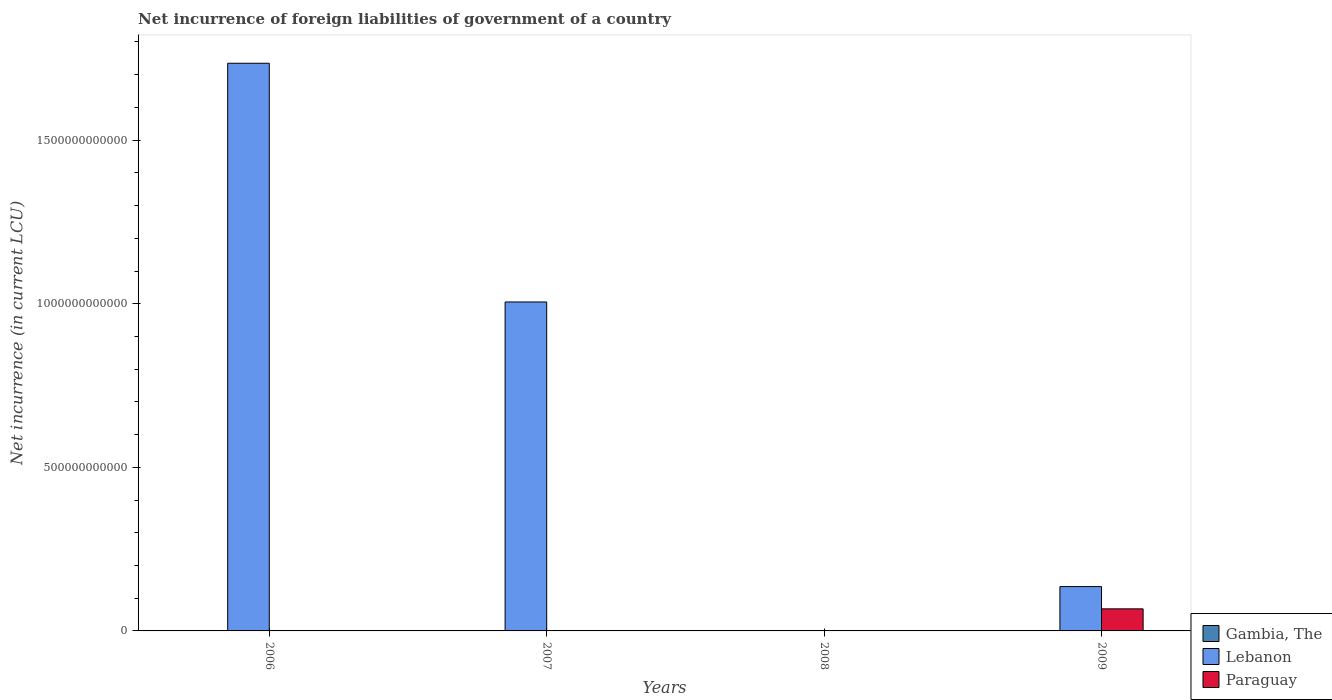Are the number of bars per tick equal to the number of legend labels?
Ensure brevity in your answer.  No. Are the number of bars on each tick of the X-axis equal?
Keep it short and to the point. No. How many bars are there on the 3rd tick from the left?
Your answer should be very brief. 1. How many bars are there on the 1st tick from the right?
Keep it short and to the point. 3. What is the label of the 2nd group of bars from the left?
Your response must be concise. 2007. In how many cases, is the number of bars for a given year not equal to the number of legend labels?
Keep it short and to the point. 3. What is the net incurrence of foreign liabilities in Gambia, The in 2008?
Give a very brief answer. 1.13e+07. Across all years, what is the maximum net incurrence of foreign liabilities in Paraguay?
Offer a terse response. 6.75e+1. Across all years, what is the minimum net incurrence of foreign liabilities in Lebanon?
Your answer should be very brief. 0. In which year was the net incurrence of foreign liabilities in Lebanon maximum?
Offer a very short reply. 2006. What is the total net incurrence of foreign liabilities in Paraguay in the graph?
Your answer should be very brief. 6.75e+1. What is the difference between the net incurrence of foreign liabilities in Gambia, The in 2007 and that in 2008?
Provide a short and direct response. 6.50e+08. What is the difference between the net incurrence of foreign liabilities in Paraguay in 2009 and the net incurrence of foreign liabilities in Gambia, The in 2006?
Offer a terse response. 6.71e+1. What is the average net incurrence of foreign liabilities in Gambia, The per year?
Offer a terse response. 2.56e+08. In the year 2009, what is the difference between the net incurrence of foreign liabilities in Paraguay and net incurrence of foreign liabilities in Gambia, The?
Your response must be concise. 6.74e+1. In how many years, is the net incurrence of foreign liabilities in Lebanon greater than 900000000000 LCU?
Keep it short and to the point. 2. What is the ratio of the net incurrence of foreign liabilities in Gambia, The in 2008 to that in 2009?
Provide a succinct answer. 0.27. Is the net incurrence of foreign liabilities in Gambia, The in 2006 less than that in 2009?
Ensure brevity in your answer.  No. What is the difference between the highest and the second highest net incurrence of foreign liabilities in Lebanon?
Make the answer very short. 7.30e+11. What is the difference between the highest and the lowest net incurrence of foreign liabilities in Paraguay?
Keep it short and to the point. 6.75e+1. Are all the bars in the graph horizontal?
Offer a terse response. No. How many years are there in the graph?
Keep it short and to the point. 4. What is the difference between two consecutive major ticks on the Y-axis?
Offer a very short reply. 5.00e+11. Does the graph contain grids?
Make the answer very short. No. How are the legend labels stacked?
Your answer should be very brief. Vertical. What is the title of the graph?
Keep it short and to the point. Net incurrence of foreign liabilities of government of a country. What is the label or title of the X-axis?
Give a very brief answer. Years. What is the label or title of the Y-axis?
Offer a very short reply. Net incurrence (in current LCU). What is the Net incurrence (in current LCU) of Gambia, The in 2006?
Your answer should be very brief. 3.09e+08. What is the Net incurrence (in current LCU) of Lebanon in 2006?
Offer a very short reply. 1.74e+12. What is the Net incurrence (in current LCU) in Gambia, The in 2007?
Offer a terse response. 6.62e+08. What is the Net incurrence (in current LCU) of Lebanon in 2007?
Offer a terse response. 1.01e+12. What is the Net incurrence (in current LCU) in Gambia, The in 2008?
Provide a succinct answer. 1.13e+07. What is the Net incurrence (in current LCU) in Paraguay in 2008?
Your response must be concise. 0. What is the Net incurrence (in current LCU) of Gambia, The in 2009?
Offer a terse response. 4.18e+07. What is the Net incurrence (in current LCU) of Lebanon in 2009?
Provide a short and direct response. 1.35e+11. What is the Net incurrence (in current LCU) in Paraguay in 2009?
Your answer should be compact. 6.75e+1. Across all years, what is the maximum Net incurrence (in current LCU) in Gambia, The?
Give a very brief answer. 6.62e+08. Across all years, what is the maximum Net incurrence (in current LCU) of Lebanon?
Give a very brief answer. 1.74e+12. Across all years, what is the maximum Net incurrence (in current LCU) of Paraguay?
Provide a short and direct response. 6.75e+1. Across all years, what is the minimum Net incurrence (in current LCU) in Gambia, The?
Offer a terse response. 1.13e+07. Across all years, what is the minimum Net incurrence (in current LCU) in Lebanon?
Give a very brief answer. 0. Across all years, what is the minimum Net incurrence (in current LCU) of Paraguay?
Give a very brief answer. 0. What is the total Net incurrence (in current LCU) in Gambia, The in the graph?
Provide a succinct answer. 1.02e+09. What is the total Net incurrence (in current LCU) in Lebanon in the graph?
Your response must be concise. 2.88e+12. What is the total Net incurrence (in current LCU) of Paraguay in the graph?
Make the answer very short. 6.75e+1. What is the difference between the Net incurrence (in current LCU) in Gambia, The in 2006 and that in 2007?
Provide a short and direct response. -3.52e+08. What is the difference between the Net incurrence (in current LCU) in Lebanon in 2006 and that in 2007?
Make the answer very short. 7.30e+11. What is the difference between the Net incurrence (in current LCU) of Gambia, The in 2006 and that in 2008?
Make the answer very short. 2.98e+08. What is the difference between the Net incurrence (in current LCU) of Gambia, The in 2006 and that in 2009?
Provide a succinct answer. 2.67e+08. What is the difference between the Net incurrence (in current LCU) of Lebanon in 2006 and that in 2009?
Your answer should be very brief. 1.60e+12. What is the difference between the Net incurrence (in current LCU) in Gambia, The in 2007 and that in 2008?
Keep it short and to the point. 6.50e+08. What is the difference between the Net incurrence (in current LCU) of Gambia, The in 2007 and that in 2009?
Provide a short and direct response. 6.20e+08. What is the difference between the Net incurrence (in current LCU) in Lebanon in 2007 and that in 2009?
Offer a very short reply. 8.70e+11. What is the difference between the Net incurrence (in current LCU) in Gambia, The in 2008 and that in 2009?
Your answer should be very brief. -3.05e+07. What is the difference between the Net incurrence (in current LCU) in Gambia, The in 2006 and the Net incurrence (in current LCU) in Lebanon in 2007?
Your response must be concise. -1.01e+12. What is the difference between the Net incurrence (in current LCU) in Gambia, The in 2006 and the Net incurrence (in current LCU) in Lebanon in 2009?
Keep it short and to the point. -1.35e+11. What is the difference between the Net incurrence (in current LCU) in Gambia, The in 2006 and the Net incurrence (in current LCU) in Paraguay in 2009?
Make the answer very short. -6.71e+1. What is the difference between the Net incurrence (in current LCU) in Lebanon in 2006 and the Net incurrence (in current LCU) in Paraguay in 2009?
Ensure brevity in your answer.  1.67e+12. What is the difference between the Net incurrence (in current LCU) in Gambia, The in 2007 and the Net incurrence (in current LCU) in Lebanon in 2009?
Provide a short and direct response. -1.35e+11. What is the difference between the Net incurrence (in current LCU) in Gambia, The in 2007 and the Net incurrence (in current LCU) in Paraguay in 2009?
Offer a terse response. -6.68e+1. What is the difference between the Net incurrence (in current LCU) in Lebanon in 2007 and the Net incurrence (in current LCU) in Paraguay in 2009?
Give a very brief answer. 9.38e+11. What is the difference between the Net incurrence (in current LCU) in Gambia, The in 2008 and the Net incurrence (in current LCU) in Lebanon in 2009?
Provide a short and direct response. -1.35e+11. What is the difference between the Net incurrence (in current LCU) of Gambia, The in 2008 and the Net incurrence (in current LCU) of Paraguay in 2009?
Give a very brief answer. -6.74e+1. What is the average Net incurrence (in current LCU) in Gambia, The per year?
Keep it short and to the point. 2.56e+08. What is the average Net incurrence (in current LCU) in Lebanon per year?
Provide a short and direct response. 7.19e+11. What is the average Net incurrence (in current LCU) of Paraguay per year?
Ensure brevity in your answer.  1.69e+1. In the year 2006, what is the difference between the Net incurrence (in current LCU) in Gambia, The and Net incurrence (in current LCU) in Lebanon?
Provide a short and direct response. -1.73e+12. In the year 2007, what is the difference between the Net incurrence (in current LCU) in Gambia, The and Net incurrence (in current LCU) in Lebanon?
Make the answer very short. -1.00e+12. In the year 2009, what is the difference between the Net incurrence (in current LCU) of Gambia, The and Net incurrence (in current LCU) of Lebanon?
Make the answer very short. -1.35e+11. In the year 2009, what is the difference between the Net incurrence (in current LCU) in Gambia, The and Net incurrence (in current LCU) in Paraguay?
Provide a succinct answer. -6.74e+1. In the year 2009, what is the difference between the Net incurrence (in current LCU) in Lebanon and Net incurrence (in current LCU) in Paraguay?
Offer a very short reply. 6.80e+1. What is the ratio of the Net incurrence (in current LCU) in Gambia, The in 2006 to that in 2007?
Offer a very short reply. 0.47. What is the ratio of the Net incurrence (in current LCU) of Lebanon in 2006 to that in 2007?
Provide a short and direct response. 1.73. What is the ratio of the Net incurrence (in current LCU) of Gambia, The in 2006 to that in 2008?
Provide a short and direct response. 27.35. What is the ratio of the Net incurrence (in current LCU) of Gambia, The in 2006 to that in 2009?
Your response must be concise. 7.39. What is the ratio of the Net incurrence (in current LCU) of Lebanon in 2006 to that in 2009?
Offer a terse response. 12.81. What is the ratio of the Net incurrence (in current LCU) of Gambia, The in 2007 to that in 2008?
Your response must be concise. 58.54. What is the ratio of the Net incurrence (in current LCU) in Gambia, The in 2007 to that in 2009?
Keep it short and to the point. 15.83. What is the ratio of the Net incurrence (in current LCU) of Lebanon in 2007 to that in 2009?
Provide a succinct answer. 7.42. What is the ratio of the Net incurrence (in current LCU) of Gambia, The in 2008 to that in 2009?
Your answer should be compact. 0.27. What is the difference between the highest and the second highest Net incurrence (in current LCU) of Gambia, The?
Offer a very short reply. 3.52e+08. What is the difference between the highest and the second highest Net incurrence (in current LCU) of Lebanon?
Your answer should be compact. 7.30e+11. What is the difference between the highest and the lowest Net incurrence (in current LCU) in Gambia, The?
Offer a terse response. 6.50e+08. What is the difference between the highest and the lowest Net incurrence (in current LCU) of Lebanon?
Provide a short and direct response. 1.74e+12. What is the difference between the highest and the lowest Net incurrence (in current LCU) in Paraguay?
Give a very brief answer. 6.75e+1. 